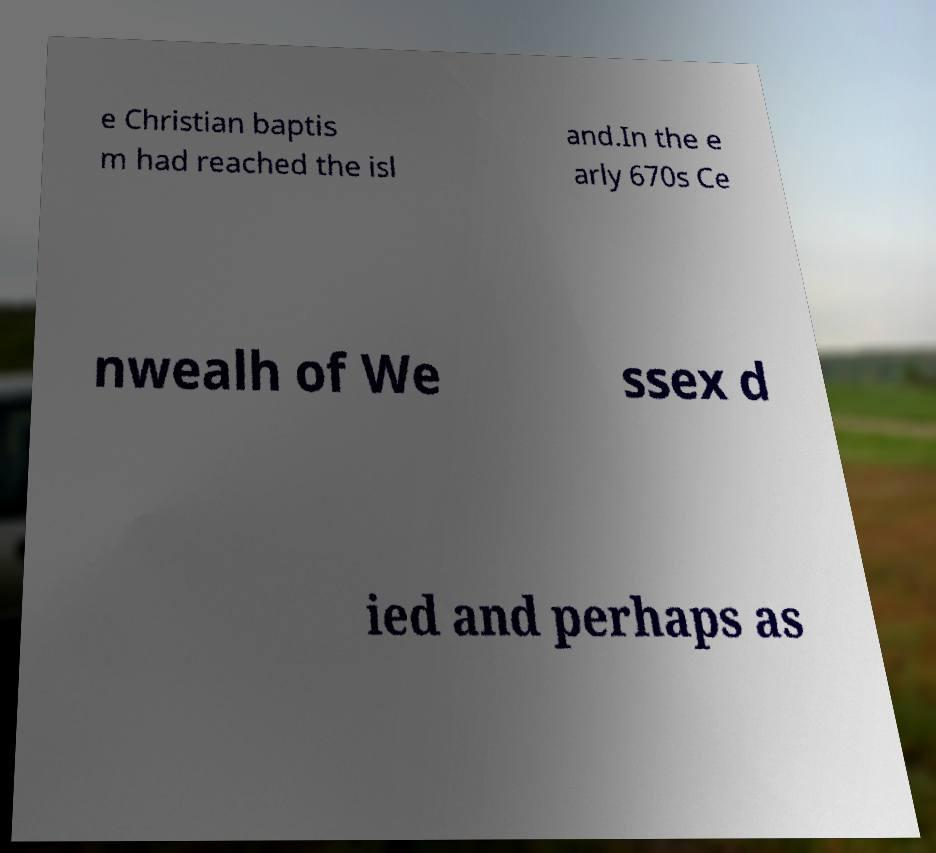Can you accurately transcribe the text from the provided image for me? e Christian baptis m had reached the isl and.In the e arly 670s Ce nwealh of We ssex d ied and perhaps as 